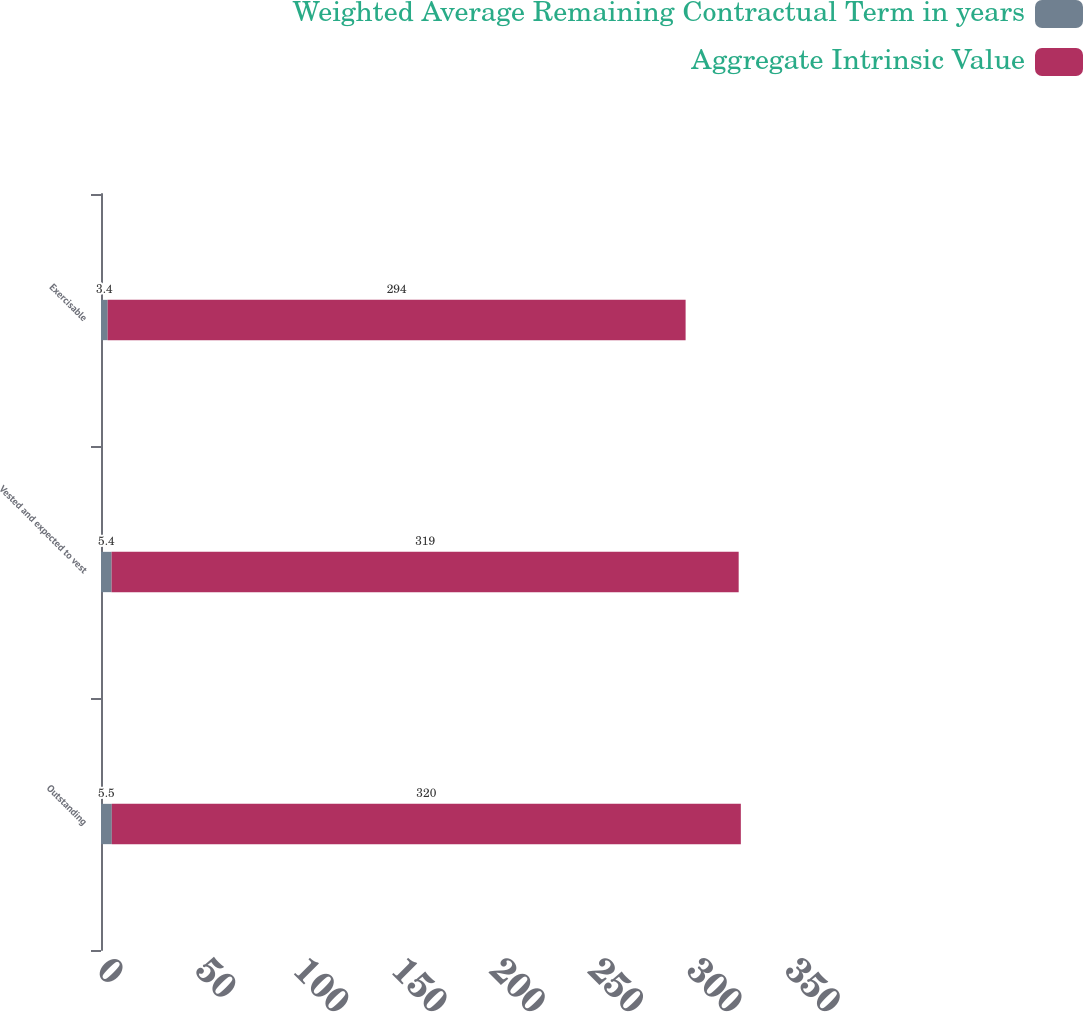Convert chart. <chart><loc_0><loc_0><loc_500><loc_500><stacked_bar_chart><ecel><fcel>Outstanding<fcel>Vested and expected to vest<fcel>Exercisable<nl><fcel>Weighted Average Remaining Contractual Term in years<fcel>5.5<fcel>5.4<fcel>3.4<nl><fcel>Aggregate Intrinsic Value<fcel>320<fcel>319<fcel>294<nl></chart> 